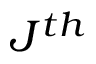<formula> <loc_0><loc_0><loc_500><loc_500>J ^ { t h }</formula> 